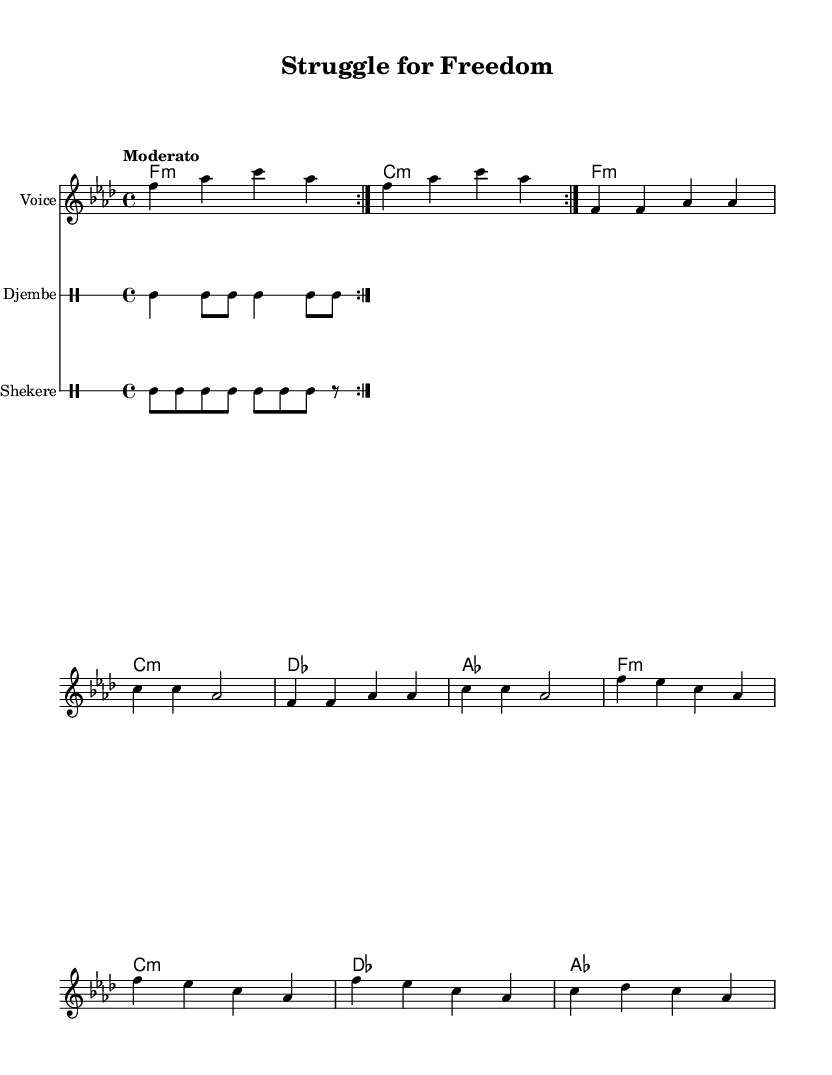What is the key signature of this music? The key signature is indicated by the 'f' on the left side of the staff, which denotes F minor, featuring four flats.
Answer: F minor What is the time signature of the piece? The time signature is located at the beginning of the score and is indicated as 4/4, meaning there are four beats in a measure and the quarter note gets one beat.
Answer: 4/4 What is the tempo marking for this piece? The tempo is marked as "Moderato," which suggests a moderate speed for the piece. This marking is typically understood to be around 108-120 beats per minute.
Answer: Moderato How many measures are in the verse section? The verse section consists of eight measures, which can be counted in the notation where the lyrics are aligned with the notes.
Answer: Eight measures What instruments are used in this piece? The score details various staves: “Voice,” “Djembe,” and “Shekere,” indicating a vocal part and two percussion instruments.
Answer: Voice, Djembe, Shekere What is the primary theme of the lyrics? The lyrics express a struggle for freedom and empowerment, as seen in phrases calling for labor recognition and freedom from chains, indicative of protest themes.
Answer: Struggle for freedom How many times is the chorus repeated? The chorus is indicated to be repeated after the verse section, suggesting it is performed twice as noted by the 'repeat volta' marking.
Answer: Twice 